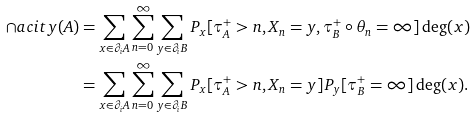<formula> <loc_0><loc_0><loc_500><loc_500>\cap a c i t y ( A ) & = \sum _ { x \in \partial _ { i } A } \sum _ { n = 0 } ^ { \infty } \sum _ { y \in \partial _ { i } B } P _ { x } [ \tau _ { A } ^ { + } > n , X _ { n } = y , \tau _ { B } ^ { + } \circ \theta _ { n } = \infty ] \deg ( x ) \\ & = \sum _ { x \in \partial _ { i } A } \sum _ { n = 0 } ^ { \infty } \sum _ { y \in \partial _ { i } B } P _ { x } [ \tau _ { A } ^ { + } > n , X _ { n } = y ] P _ { y } [ \tau _ { B } ^ { + } = \infty ] \deg ( x ) .</formula> 